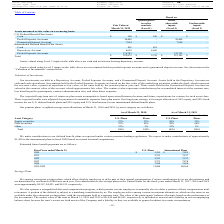From Avx Corporation's financial document, What are the future benefit payments of U.S. Plans for the fiscal years ended March 31, 2020 to 2022? The document contains multiple relevant values: 2,295, 2,333, 2,353. From the document: "2020 $ 2,295 $ 7,055 2021 2,333 7,197 2022 2,353 7,337..." Also, What are the future benefit payments of U.S. Plans for the fiscal years ended March 31, 2022 to 2024? The document contains multiple relevant values: 2,353, 2,371, 2,388. From the document: "2024 2,388 7,624 2022 2,353 7,337 2023 2,371 7,478..." Also, What are the future benefit payments of International Plans for the fiscal years ended March 31, 2020 to 2022? The document contains multiple relevant values: 7,055, 7,197, 7,337. From the document: "2021 2,333 7,197 2022 2,353 7,337 2020 $ 2,295 $ 7,055..." Also, can you calculate: What is the difference in the 2020 U.S. and International plans? Based on the calculation: 7,055 - 2,295 , the result is 4760. This is based on the information: "2020 $ 2,295 $ 7,055 2020 $ 2,295 $ 7,055..." The key data points involved are: 2,295, 7,055. Also, can you calculate: What is the total and estimated future benefits payments for the years ended March 31, 2017 to 2020 for the U.S.? Based on the calculation: 4,367 + 4,421 + 4,913 + 2,295 , the result is 15996. This is based on the information: "2020 $ 2,295 $ 7,055 , 2017, 2018 and 2019 were approximately $4,367, $4,421, and $4,913, respectively. and 2019 were approximately $4,367, $4,421, and $4,913, respectively. March 31, 2017, 2018 and 2..." The key data points involved are: 2,295, 4,367, 4,421. Also, can you calculate: What is the percentage change in the estimated future benefit payments between 2020 and 2021 for the international plans? To answer this question, I need to perform calculations using the financial data. The calculation is: (7,197 - 7,055)/7,055 , which equals 2.01 (percentage). This is based on the information: "2020 $ 2,295 $ 7,055 2021 2,333 7,197..." The key data points involved are: 7,055, 7,197. 